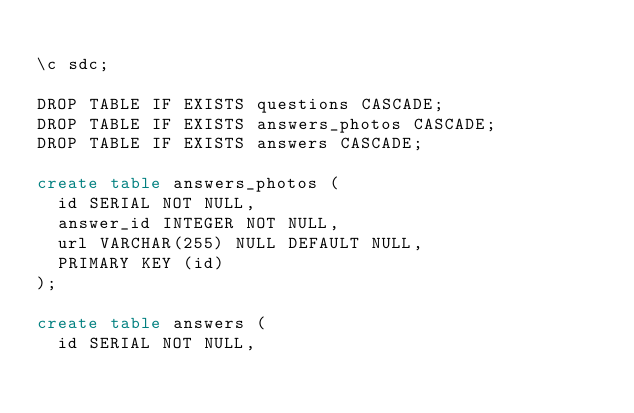<code> <loc_0><loc_0><loc_500><loc_500><_SQL_>
\c sdc;

DROP TABLE IF EXISTS questions CASCADE;
DROP TABLE IF EXISTS answers_photos CASCADE;
DROP TABLE IF EXISTS answers CASCADE;

create table answers_photos (
  id SERIAL NOT NULL,
  answer_id INTEGER NOT NULL,
  url VARCHAR(255) NULL DEFAULT NULL,
  PRIMARY KEY (id)
);

create table answers (
  id SERIAL NOT NULL,</code> 